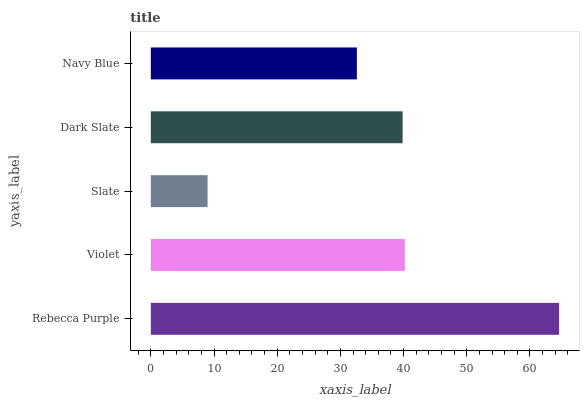Is Slate the minimum?
Answer yes or no. Yes. Is Rebecca Purple the maximum?
Answer yes or no. Yes. Is Violet the minimum?
Answer yes or no. No. Is Violet the maximum?
Answer yes or no. No. Is Rebecca Purple greater than Violet?
Answer yes or no. Yes. Is Violet less than Rebecca Purple?
Answer yes or no. Yes. Is Violet greater than Rebecca Purple?
Answer yes or no. No. Is Rebecca Purple less than Violet?
Answer yes or no. No. Is Dark Slate the high median?
Answer yes or no. Yes. Is Dark Slate the low median?
Answer yes or no. Yes. Is Slate the high median?
Answer yes or no. No. Is Navy Blue the low median?
Answer yes or no. No. 